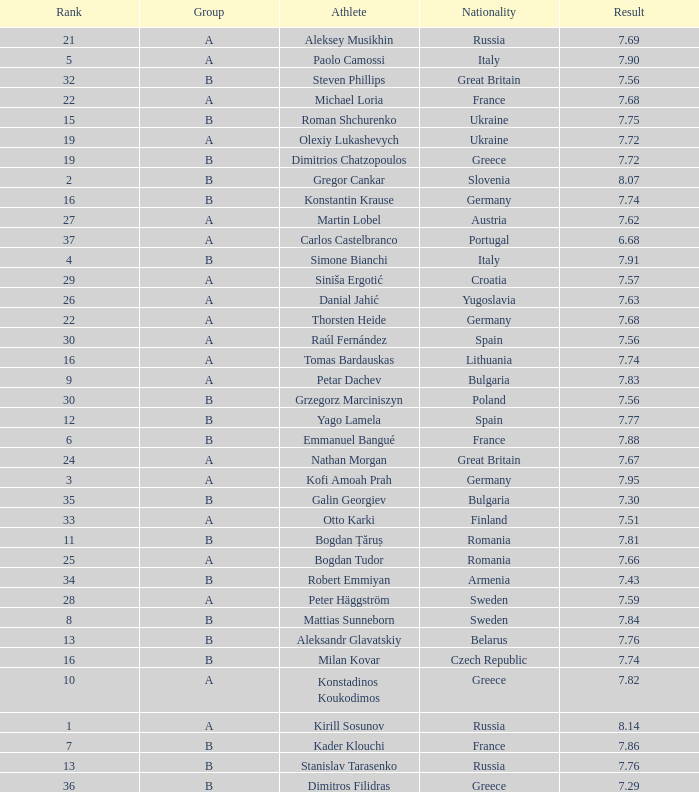Which athlete's rank is more than 15 when the result is less than 7.68, the group is b, and the nationality listed is Great Britain? Steven Phillips. 